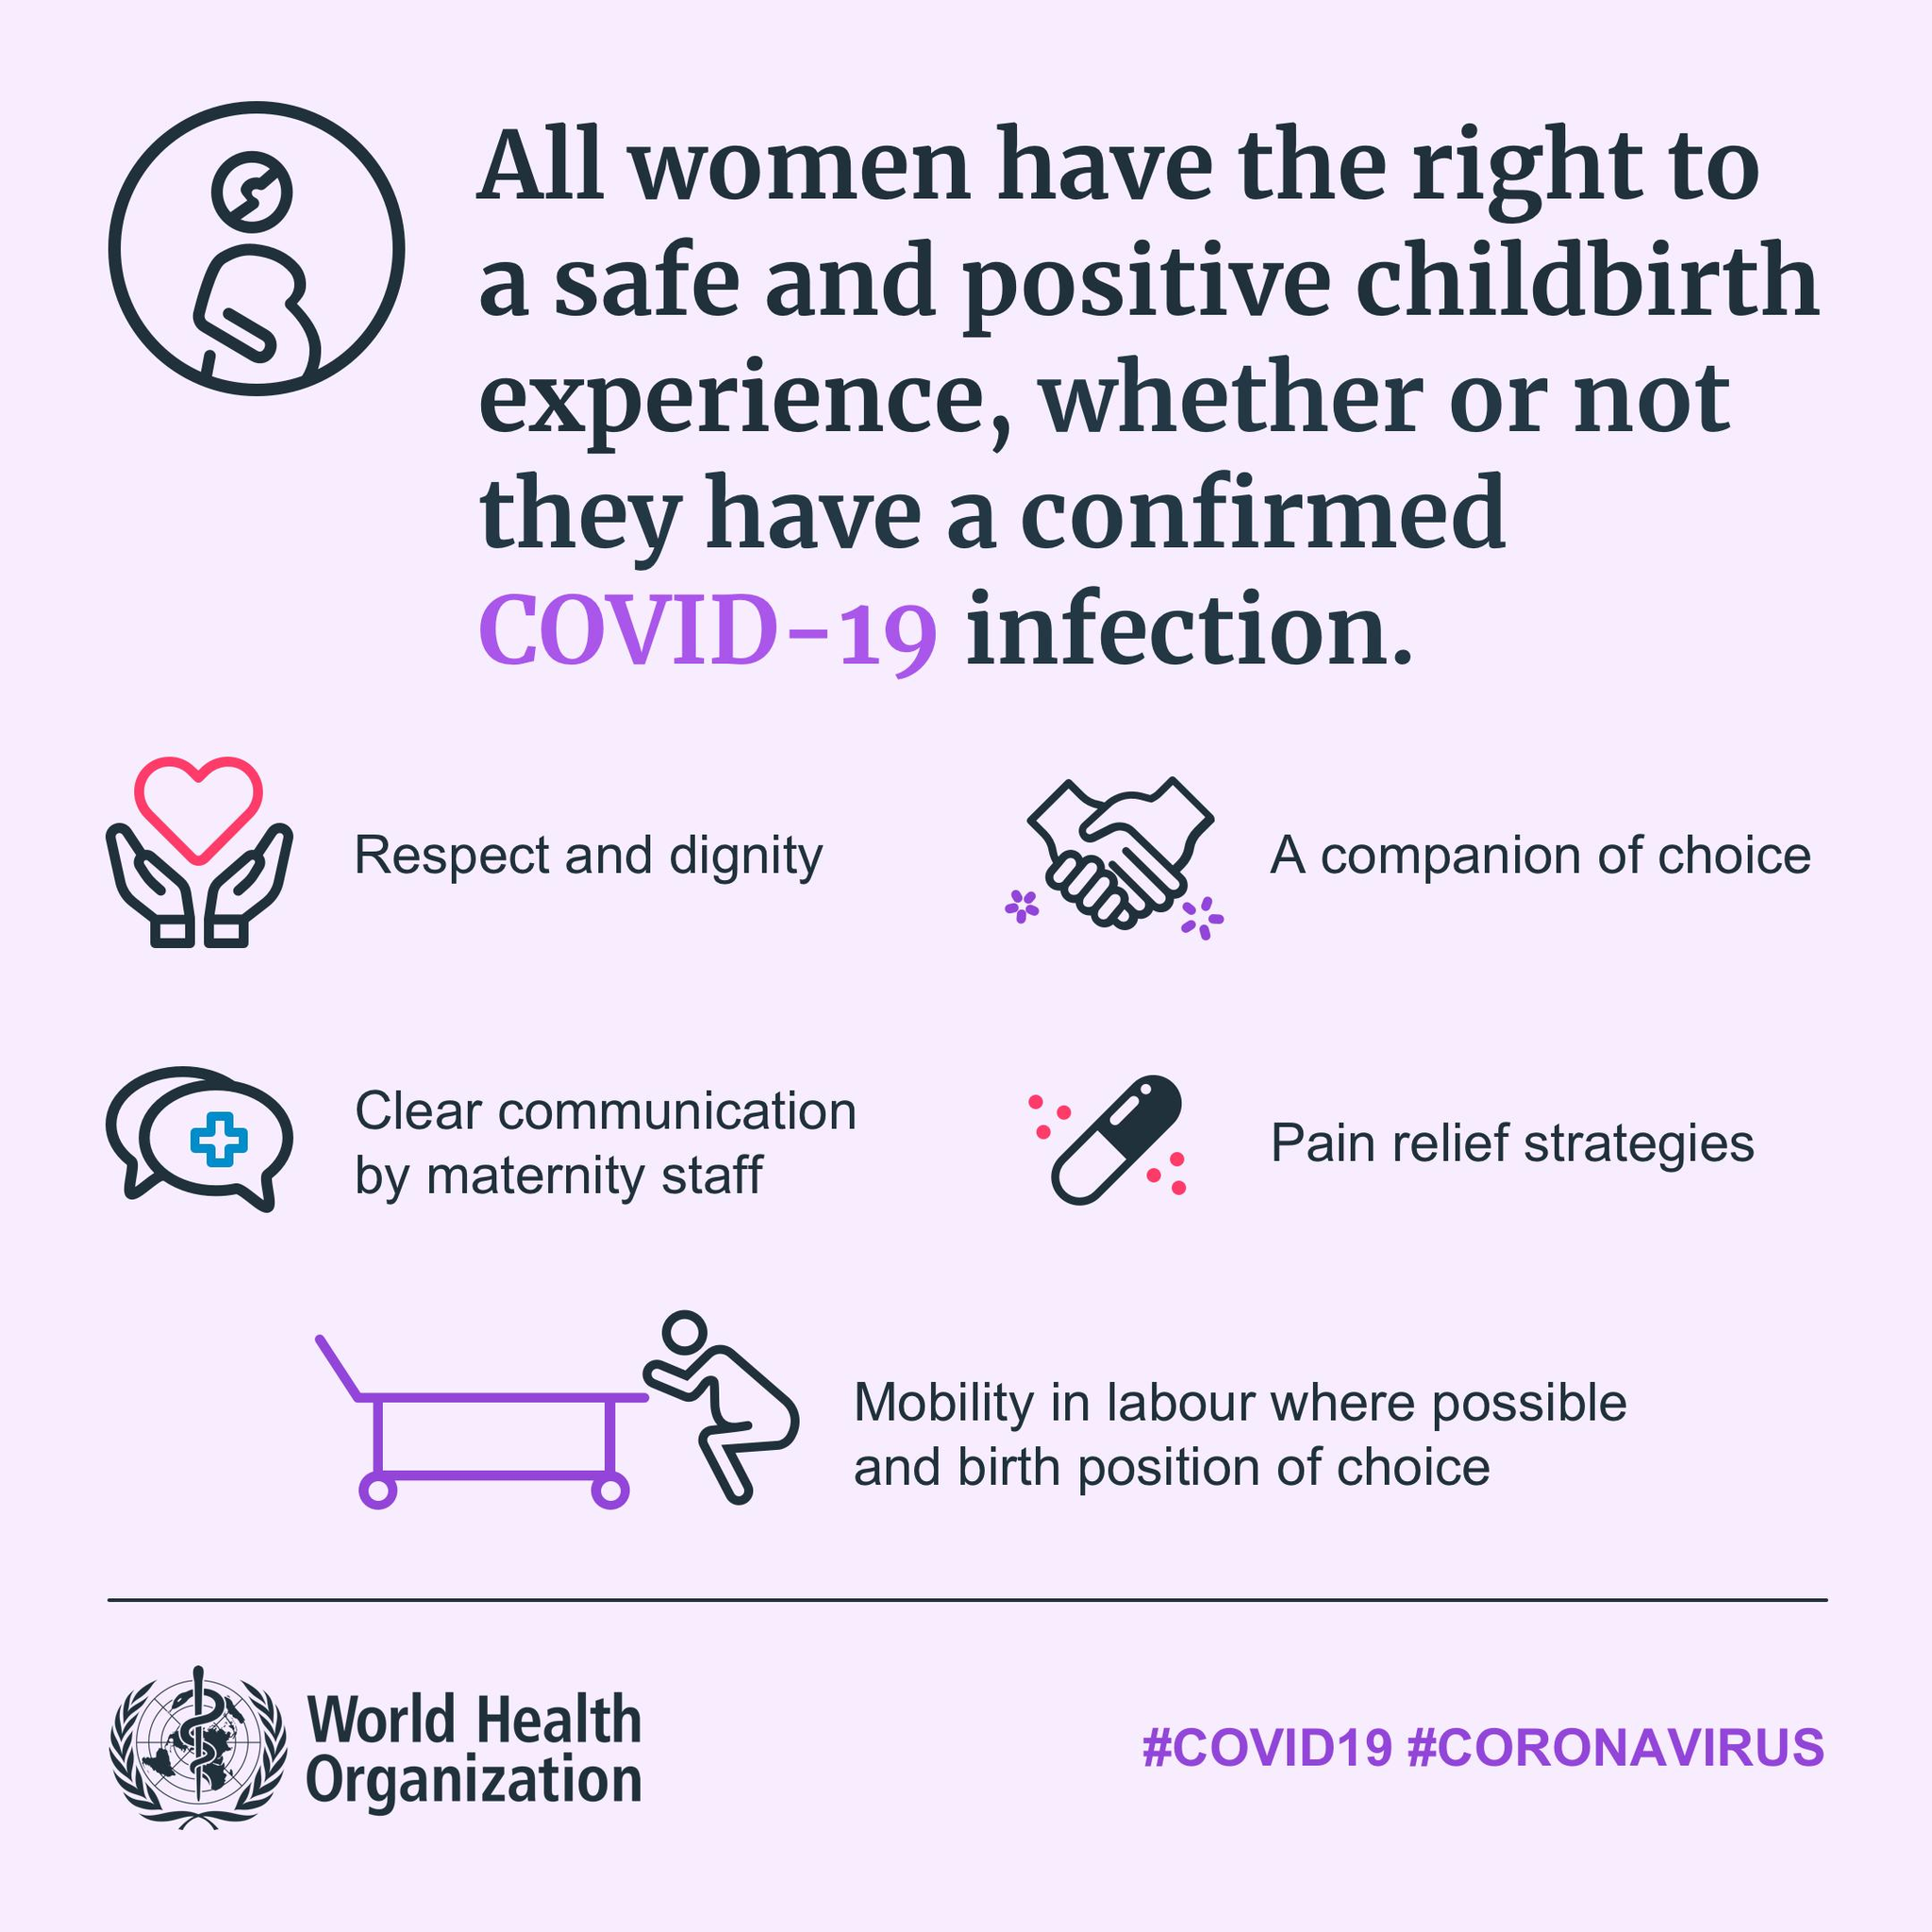Highlight a few significant elements in this photo. Mobility in labor, where possible, and the ability to assume a desired birth position are the final requisites for ensuring a safe and positive childbirth experience. The image of a heart is used to represent respect and dignity, a requisite in the field of customer service. The image of a handshake represents the companion of choice. Maternity staff is responsible for making clear communication. The image of a capsule is representative of the requisite Pain Relief Strategies. 